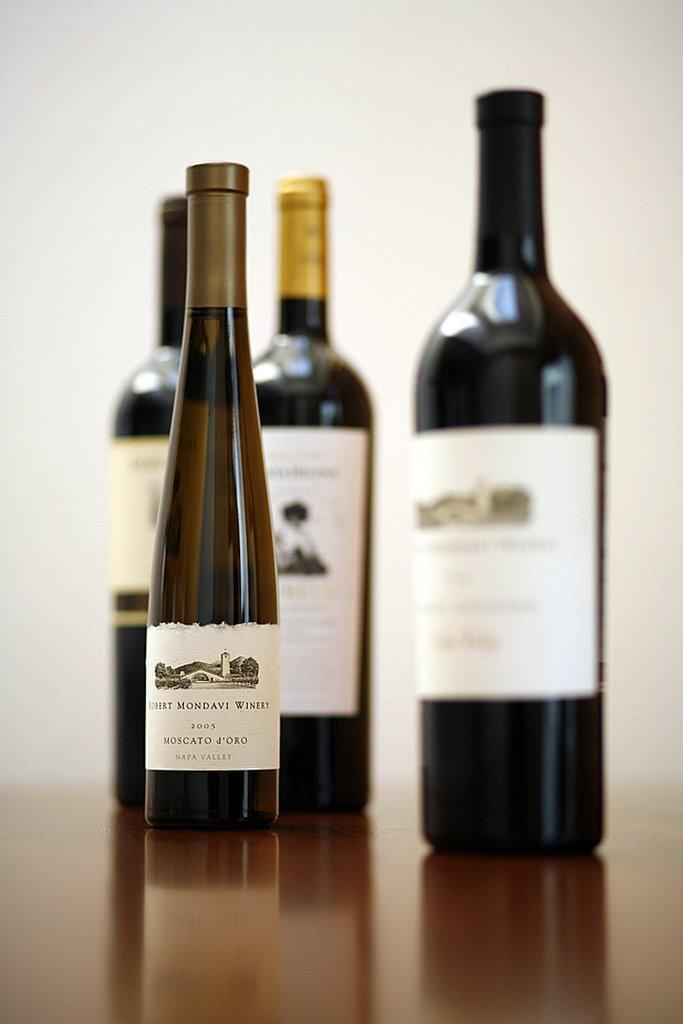<image>
Summarize the visual content of the image. Robert Modavi 2005 is labeled on this bottle of wine. 